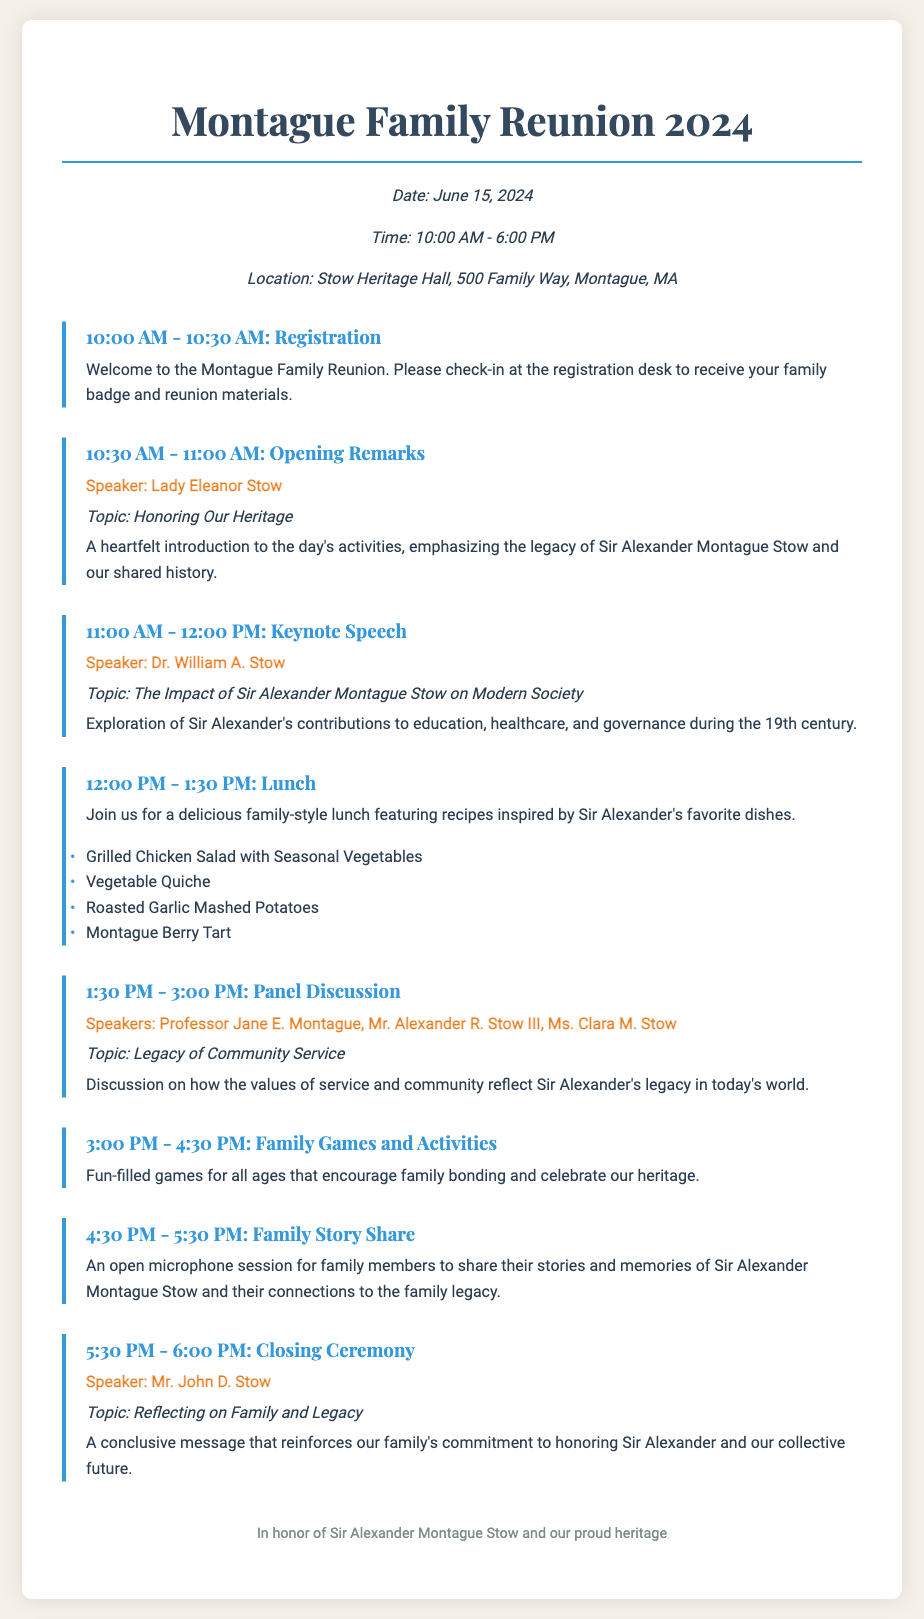What is the date of the reunion? The date is specified in the event details section of the document.
Answer: June 15, 2024 Who is the speaker for the Opening Remarks? The speaker for the Opening Remarks is mentioned along with her title in the agenda section.
Answer: Lady Eleanor Stow What is the topic of the Keynote Speech? The Keynote Speech topic is detailed immediately following the speaker's name in the agenda.
Answer: The Impact of Sir Alexander Montague Stow on Modern Society What time does registration begin? The starting time for registration is mentioned at the top of the agenda items.
Answer: 10:00 AM How long is the Lunch break? The duration of the Lunch break is indicated in the corresponding agenda item.
Answer: 1 hour 30 minutes Who are the speakers in the Panel Discussion? The names of all the speakers for the Panel Discussion are listed together in the agenda item.
Answer: Professor Jane E. Montague, Mr. Alexander R. Stow III, Ms. Clara M. Stow What is included in the family-style lunch? The document lists specific dishes served during the lunch in the corresponding agenda section.
Answer: Grilled Chicken Salad, Vegetable Quiche, Roasted Garlic Mashed Potatoes, Montague Berry Tart What is the focus of the Family Story Share? The purpose of the Family Story Share is described in the agenda item detailing this activity.
Answer: Sharing stories and memories of Sir Alexander Montague Stow What is the location of the reunion? The location is clearly stated in the event details at the beginning of the document.
Answer: Stow Heritage Hall, 500 Family Way, Montague, MA 